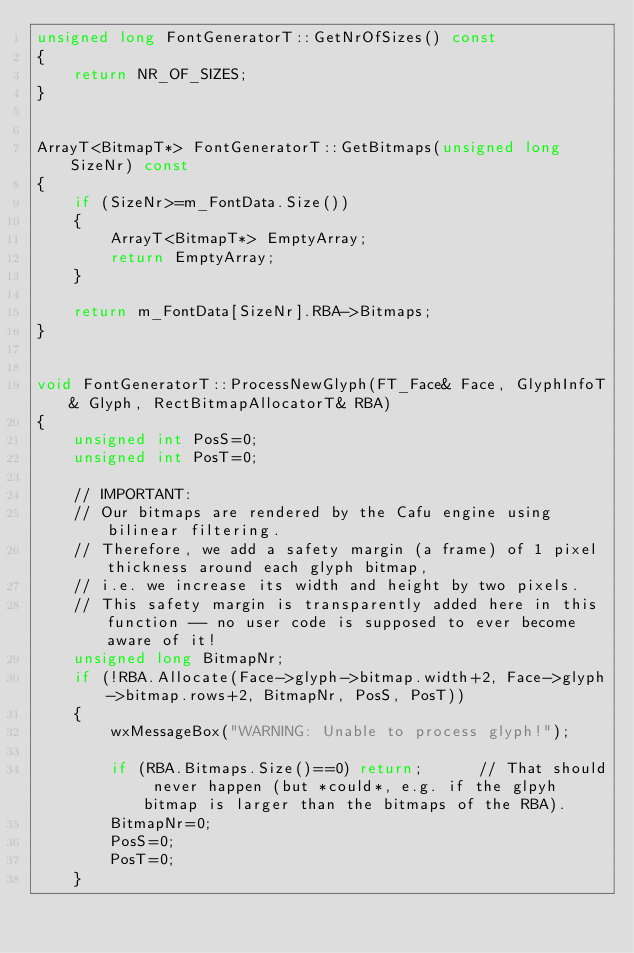Convert code to text. <code><loc_0><loc_0><loc_500><loc_500><_C++_>unsigned long FontGeneratorT::GetNrOfSizes() const
{
    return NR_OF_SIZES;
}


ArrayT<BitmapT*> FontGeneratorT::GetBitmaps(unsigned long SizeNr) const
{
    if (SizeNr>=m_FontData.Size())
    {
        ArrayT<BitmapT*> EmptyArray;
        return EmptyArray;
    }

    return m_FontData[SizeNr].RBA->Bitmaps;
}


void FontGeneratorT::ProcessNewGlyph(FT_Face& Face, GlyphInfoT& Glyph, RectBitmapAllocatorT& RBA)
{
    unsigned int PosS=0;
    unsigned int PosT=0;

    // IMPORTANT:
    // Our bitmaps are rendered by the Cafu engine using bilinear filtering.
    // Therefore, we add a safety margin (a frame) of 1 pixel thickness around each glyph bitmap,
    // i.e. we increase its width and height by two pixels.
    // This safety margin is transparently added here in this function -- no user code is supposed to ever become aware of it!
    unsigned long BitmapNr;
    if (!RBA.Allocate(Face->glyph->bitmap.width+2, Face->glyph->bitmap.rows+2, BitmapNr, PosS, PosT))
    {
        wxMessageBox("WARNING: Unable to process glyph!");

        if (RBA.Bitmaps.Size()==0) return;      // That should never happen (but *could*, e.g. if the glpyh bitmap is larger than the bitmaps of the RBA).
        BitmapNr=0;
        PosS=0;
        PosT=0;
    }
</code> 